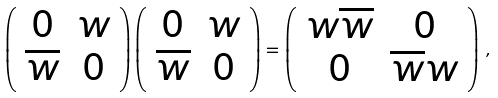<formula> <loc_0><loc_0><loc_500><loc_500>\left ( \begin{array} { c c } 0 & w \\ \overline { w } & 0 \end{array} \right ) \left ( \begin{array} { c c } 0 & w \\ \overline { w } & 0 \end{array} \right ) = \left ( \begin{array} { c c } w \overline { w } & 0 \\ 0 & \overline { w } w \end{array} \right ) \, ,</formula> 